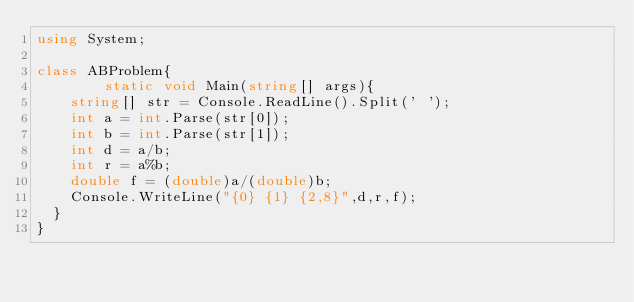<code> <loc_0><loc_0><loc_500><loc_500><_C#_>using System;

class ABProblem{
        static void Main(string[] args){
	  string[] str = Console.ReadLine().Split(' ');
	  int a = int.Parse(str[0]);
	  int b = int.Parse(str[1]);
	  int d = a/b;
	  int r = a%b;
	  double f = (double)a/(double)b;
	  Console.WriteLine("{0} {1} {2,8}",d,r,f);
	}
}</code> 